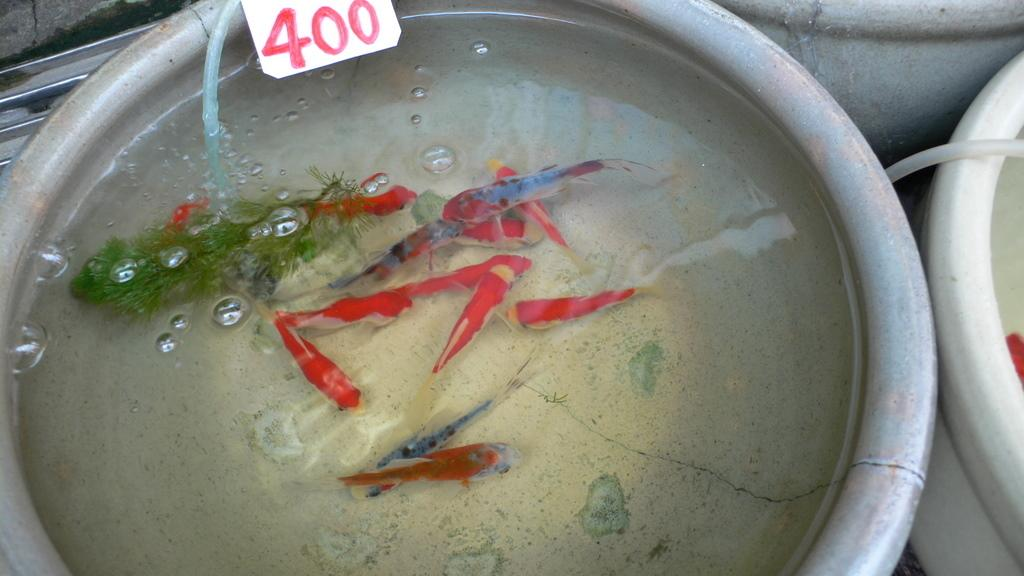What is in the bowl that is visible in the image? The bowl contains water. What is present in the water in the image? There are fishes in the water. What other objects can be seen in the image? There is a pipe and a white paper in the image. What is written on the white paper? The white paper has a number on it. How does the doll help to clear the throat in the image? There is no doll present in the image, so it cannot help to clear the throat. 